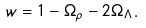<formula> <loc_0><loc_0><loc_500><loc_500>w = 1 - \Omega _ { \rho } - 2 \Omega _ { \Lambda } .</formula> 